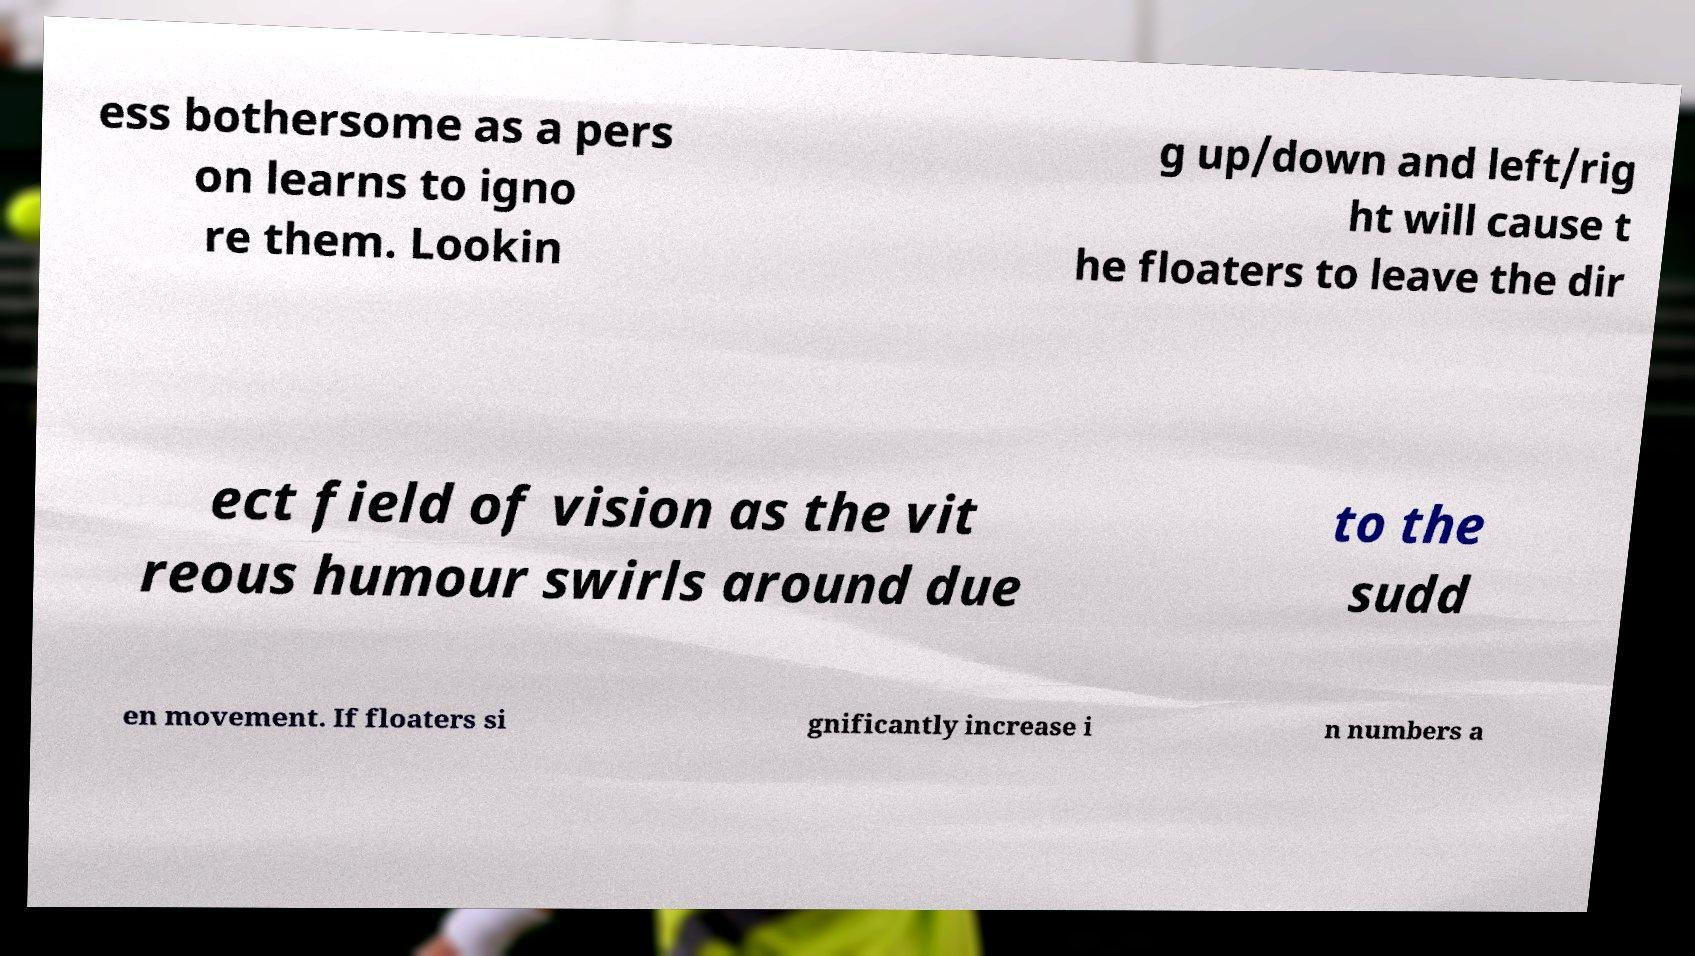For documentation purposes, I need the text within this image transcribed. Could you provide that? ess bothersome as a pers on learns to igno re them. Lookin g up/down and left/rig ht will cause t he floaters to leave the dir ect field of vision as the vit reous humour swirls around due to the sudd en movement. If floaters si gnificantly increase i n numbers a 